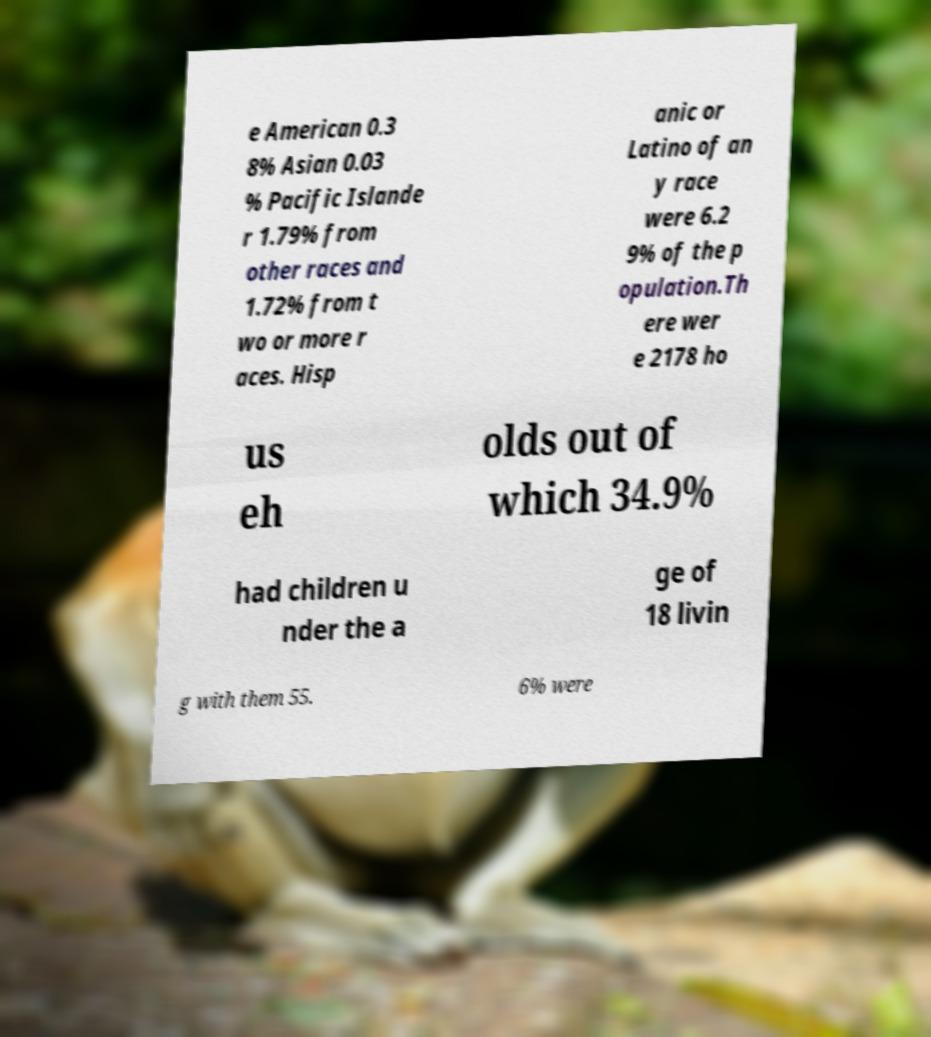Can you read and provide the text displayed in the image?This photo seems to have some interesting text. Can you extract and type it out for me? e American 0.3 8% Asian 0.03 % Pacific Islande r 1.79% from other races and 1.72% from t wo or more r aces. Hisp anic or Latino of an y race were 6.2 9% of the p opulation.Th ere wer e 2178 ho us eh olds out of which 34.9% had children u nder the a ge of 18 livin g with them 55. 6% were 